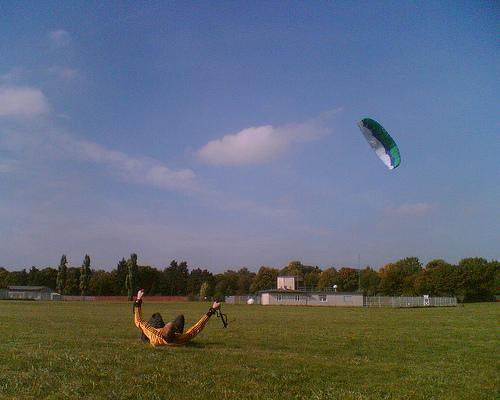How many kites are there?
Give a very brief answer. 1. 